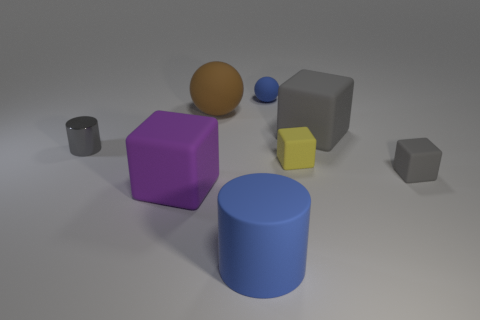Is there any other thing that is made of the same material as the tiny cylinder?
Provide a short and direct response. No. Are there more small gray objects in front of the metallic cylinder than blue cylinders that are on the left side of the big blue cylinder?
Provide a short and direct response. Yes. There is a tiny thing that is behind the cylinder to the left of the large rubber cube left of the large blue rubber cylinder; what is its color?
Keep it short and to the point. Blue. Is the color of the rubber cylinder in front of the blue matte sphere the same as the tiny sphere?
Offer a terse response. Yes. What number of other things are the same color as the metal thing?
Provide a succinct answer. 2. How many things are gray things or large blue metallic things?
Your answer should be compact. 3. What number of things are large cylinders or large rubber objects that are behind the big blue rubber cylinder?
Your answer should be very brief. 4. Is the material of the large blue object the same as the big gray cube?
Ensure brevity in your answer.  Yes. How many other objects are there of the same material as the brown thing?
Ensure brevity in your answer.  6. Is the number of metal cylinders greater than the number of big rubber cubes?
Give a very brief answer. No. 